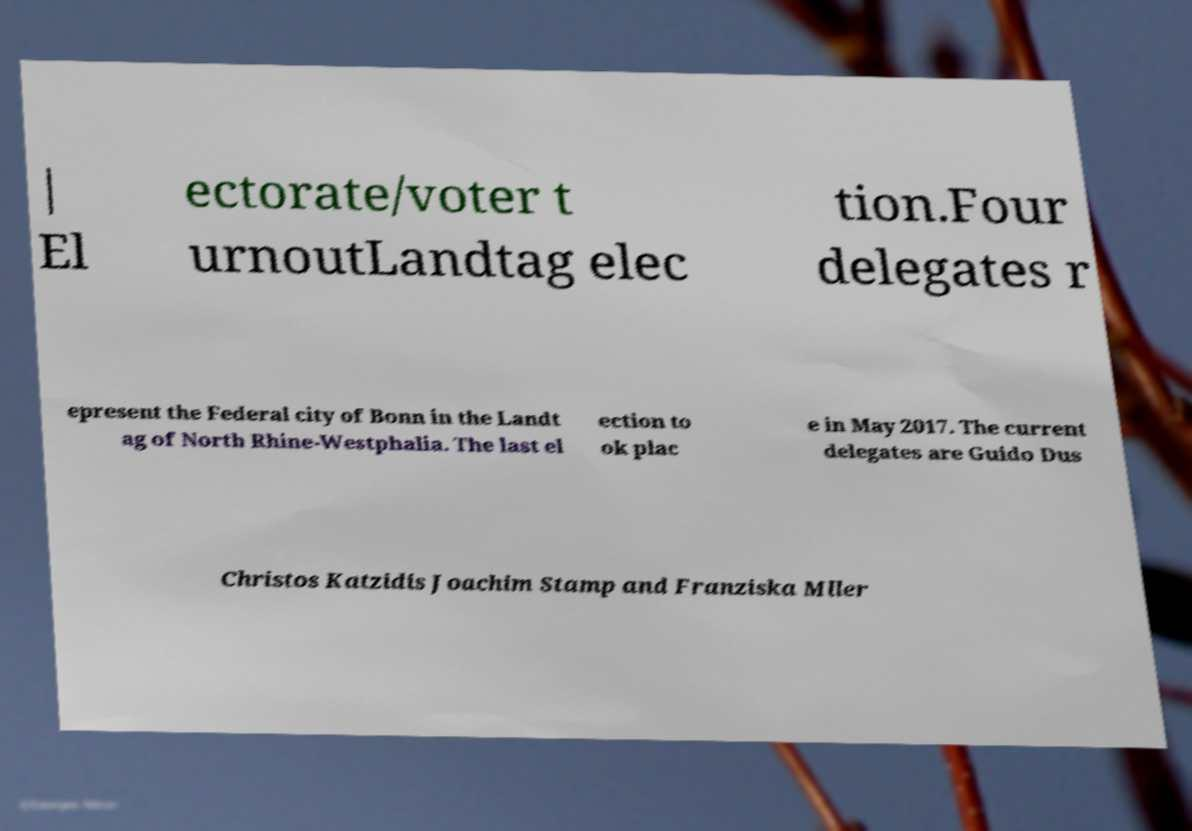Please identify and transcribe the text found in this image. | El ectorate/voter t urnoutLandtag elec tion.Four delegates r epresent the Federal city of Bonn in the Landt ag of North Rhine-Westphalia. The last el ection to ok plac e in May 2017. The current delegates are Guido Dus Christos Katzidis Joachim Stamp and Franziska Mller 